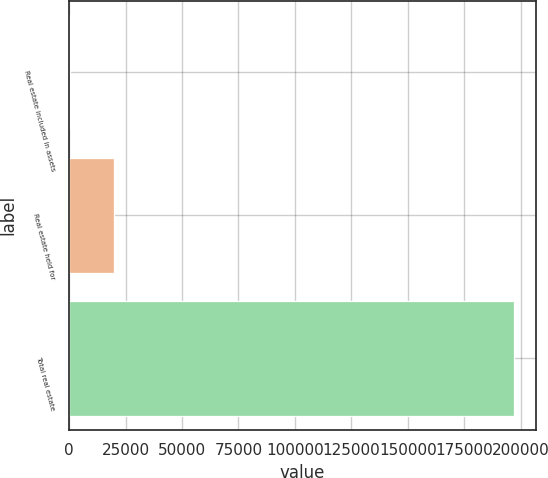<chart> <loc_0><loc_0><loc_500><loc_500><bar_chart><fcel>Real estate included in assets<fcel>Real estate held for<fcel>Total real estate<nl><fcel>248<fcel>19908.3<fcel>196851<nl></chart> 